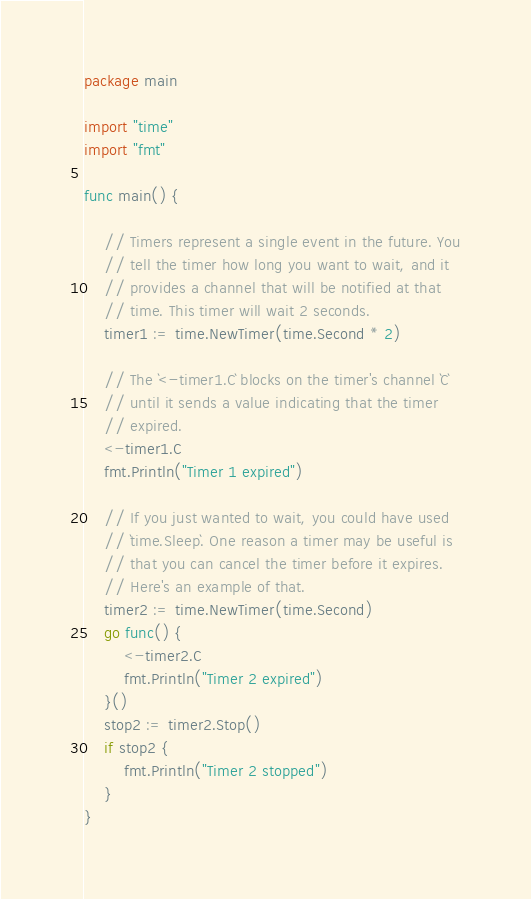Convert code to text. <code><loc_0><loc_0><loc_500><loc_500><_Go_>package main

import "time"
import "fmt"

func main() {

    // Timers represent a single event in the future. You
    // tell the timer how long you want to wait, and it
    // provides a channel that will be notified at that
    // time. This timer will wait 2 seconds.
    timer1 := time.NewTimer(time.Second * 2)

    // The `<-timer1.C` blocks on the timer's channel `C`
    // until it sends a value indicating that the timer
    // expired.
    <-timer1.C
    fmt.Println("Timer 1 expired")

    // If you just wanted to wait, you could have used
    // `time.Sleep`. One reason a timer may be useful is
    // that you can cancel the timer before it expires.
    // Here's an example of that.
    timer2 := time.NewTimer(time.Second)
    go func() {
        <-timer2.C
        fmt.Println("Timer 2 expired")
    }()
    stop2 := timer2.Stop()
    if stop2 {
        fmt.Println("Timer 2 stopped")
    }
}
</code> 